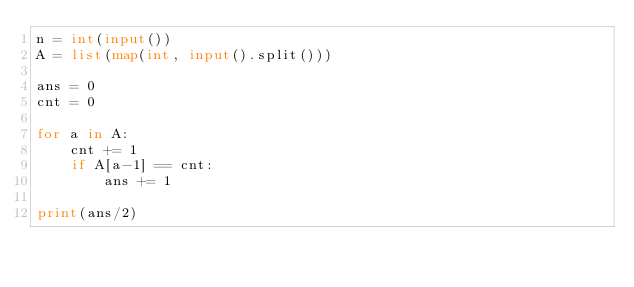Convert code to text. <code><loc_0><loc_0><loc_500><loc_500><_Python_>n = int(input())
A = list(map(int, input().split()))

ans = 0
cnt = 0

for a in A:
    cnt += 1
    if A[a-1] == cnt:
        ans += 1

print(ans/2)
</code> 